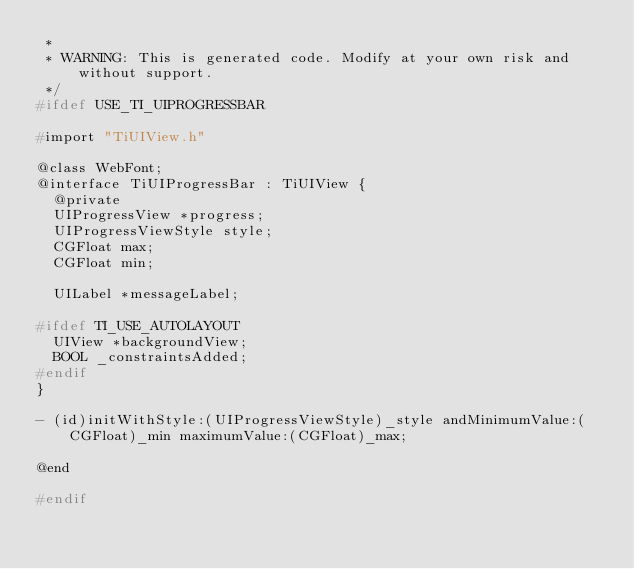<code> <loc_0><loc_0><loc_500><loc_500><_C_> * 
 * WARNING: This is generated code. Modify at your own risk and without support.
 */
#ifdef USE_TI_UIPROGRESSBAR

#import "TiUIView.h"

@class WebFont;
@interface TiUIProgressBar : TiUIView {
  @private
  UIProgressView *progress;
  UIProgressViewStyle style;
  CGFloat max;
  CGFloat min;

  UILabel *messageLabel;

#ifdef TI_USE_AUTOLAYOUT
  UIView *backgroundView;
  BOOL _constraintsAdded;
#endif
}

- (id)initWithStyle:(UIProgressViewStyle)_style andMinimumValue:(CGFloat)_min maximumValue:(CGFloat)_max;

@end

#endif
</code> 